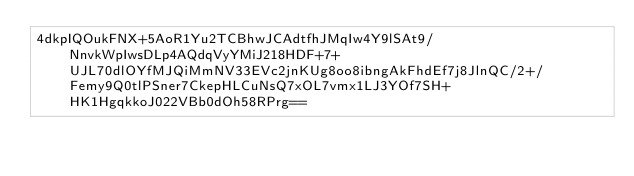Convert code to text. <code><loc_0><loc_0><loc_500><loc_500><_SML_>4dkpIQOukFNX+5AoR1Yu2TCBhwJCAdtfhJMqIw4Y9lSAt9/NnvkWpIwsDLp4AQdqVyYMiJ218HDF+7+UJL70dlOYfMJQiMmNV33EVc2jnKUg8oo8ibngAkFhdEf7j8JlnQC/2+/Femy9Q0tlPSner7CkepHLCuNsQ7xOL7vmx1LJ3YOf7SH+HK1HgqkkoJ022VBb0dOh58RPrg==</code> 